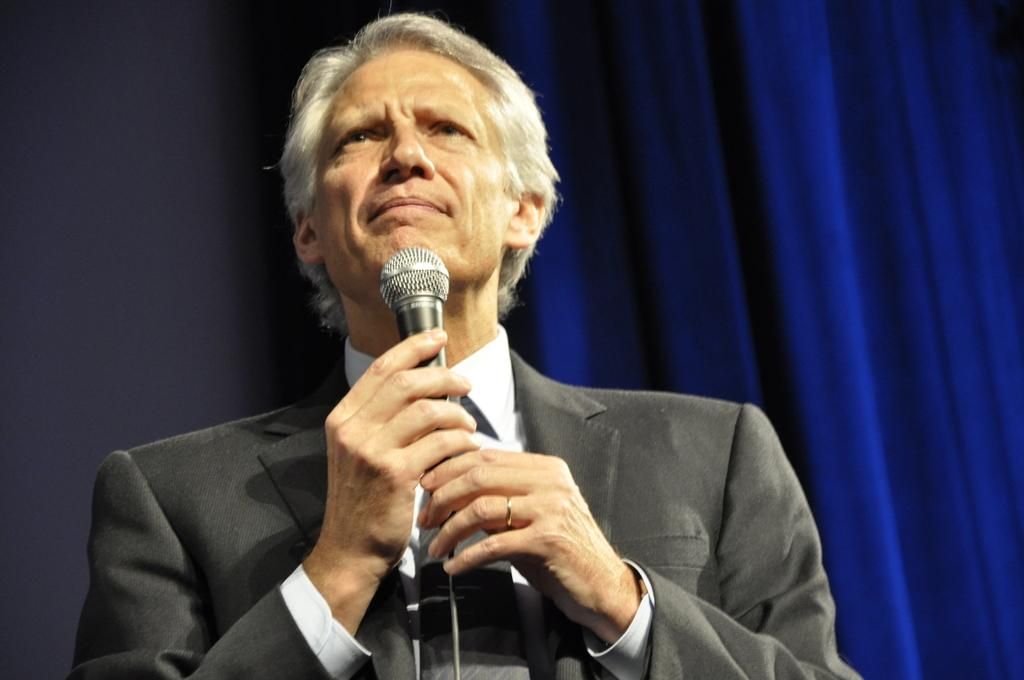Who or what is the main subject of the image? There is a person in the image. What is the person wearing? The person is wearing a suit. What is the person holding in their hands? The person is holding a microphone in their hands. What color is the background of the image? The background of the image is blue. Is there a collar visible on the person in the image? There is no collar mentioned in the provided facts, so we cannot determine if there is one visible in the image. 